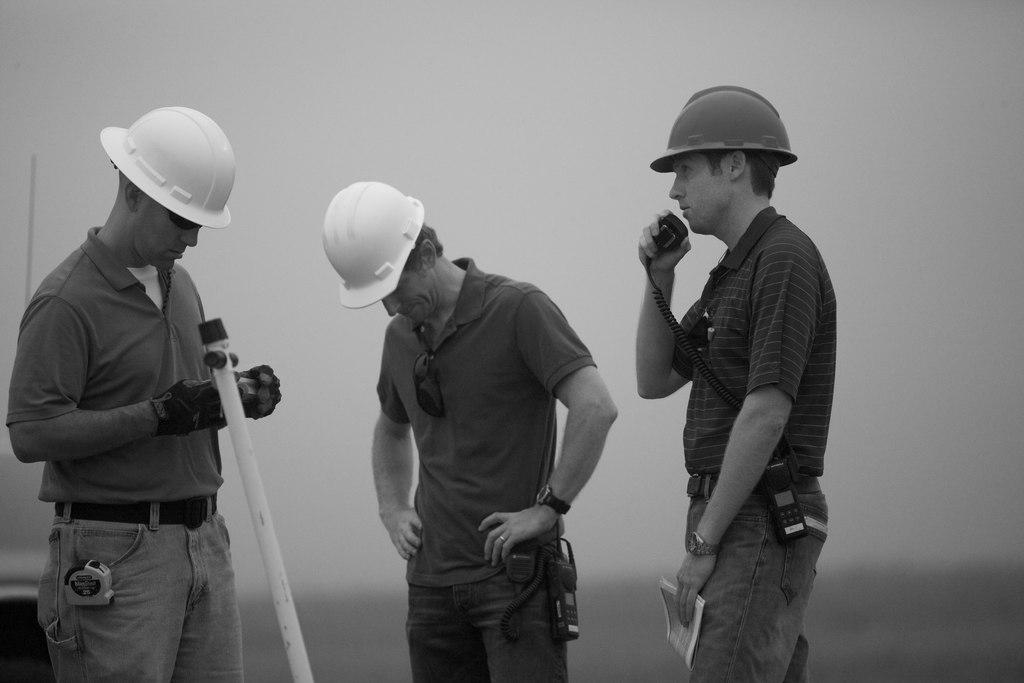How many people are in the image? There are three people standing in the image. Where is one of the people located in the image? One of the people is on the left side of the image. What is on the left side of the image besides the person? There is a pole on the left side of the image. What are the people wearing on their heads? The people are wearing caps. What is the person on the right side of the image doing? The person on the right side of the image is holding an object. How would you describe the background of the image? The background of the image is blurry. How does the person on the left side of the image feel about the rain in the image? There is no mention of rain in the image, so it is not possible to determine how the person feels about it. 